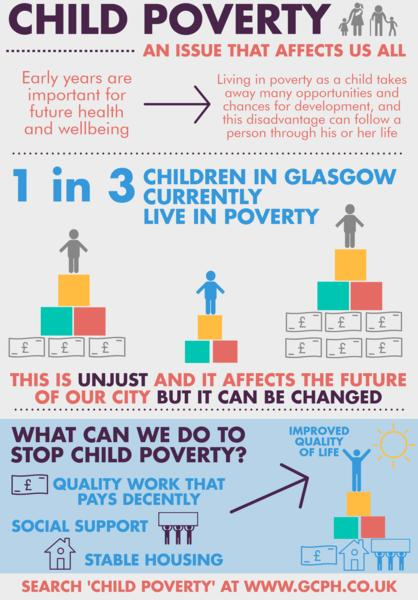List a handful of essential elements in this visual. The solution to alleviating child poverty lists three factors. According to recent data, 33.33% of children living in Glasgow are currently living in poverty. 